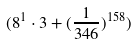<formula> <loc_0><loc_0><loc_500><loc_500>( 8 ^ { 1 } \cdot 3 + ( \frac { 1 } { 3 4 6 } ) ^ { 1 5 8 } )</formula> 